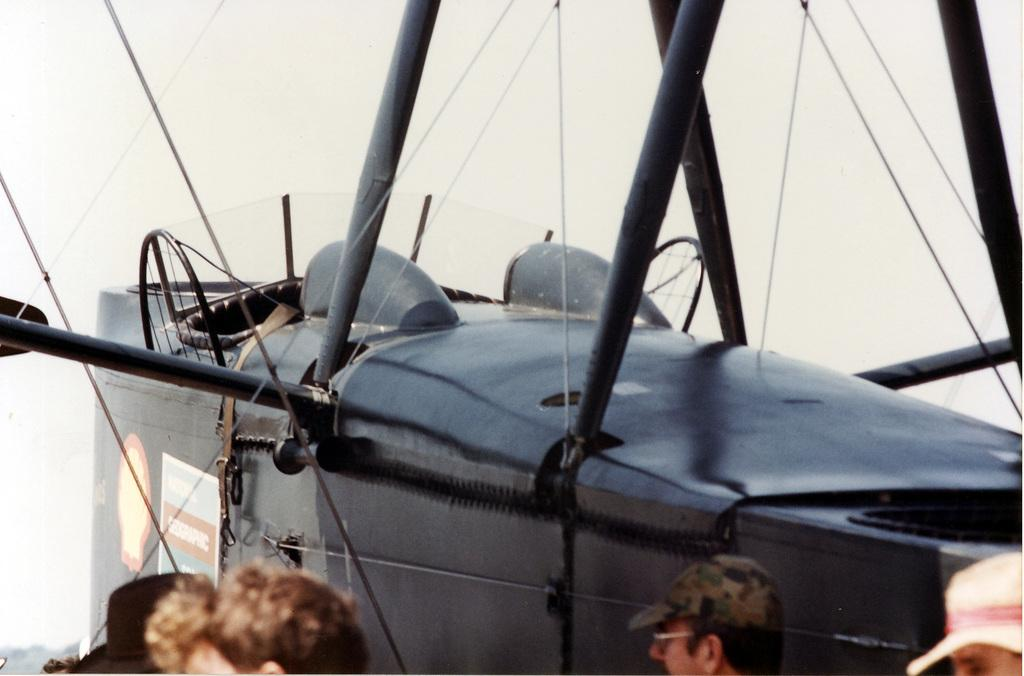How many people are in the image? There is a group of people in the image, but the exact number cannot be determined from the provided facts. What type of vehicle-like object is in the image? The facts do not specify the type of vehicle-like object in the image. What are the metal rods used for in the image? The purpose of the metal rods in the image cannot be determined from the provided facts. What type of vegetation is present in the image? There are trees in the image. What is visible in the sky in the image? The sky is visible in the image, but the specific conditions cannot be determined from the provided facts. Can you tell if the image was taken during the day or night? The image was likely taken during the day, as the sky is visible and there is no mention of darkness or artificial lighting. What type of pest can be seen crawling on the bed in the image? There is no bed or pest present in the image. Can you describe the misty conditions in the image? There is no mention of mist in the provided facts, and the sky is visible, suggesting clear conditions. 